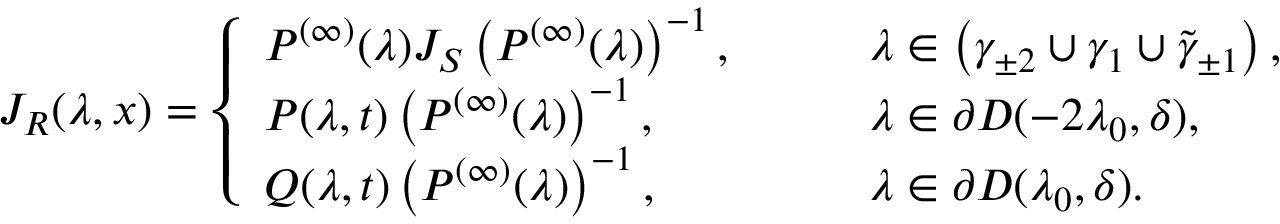<formula> <loc_0><loc_0><loc_500><loc_500>J _ { R } ( \lambda , x ) = \left \{ \begin{array} { l l } { P ^ { ( \infty ) } ( \lambda ) J _ { S } \left ( P ^ { ( \infty ) } ( \lambda ) \right ) ^ { - 1 } , } & { \quad \lambda \in \left ( \gamma _ { \pm 2 } \cup \gamma _ { 1 } \cup \tilde { \gamma } _ { \pm 1 } \right ) , } \\ { P ( \lambda , t ) \left ( P ^ { ( \infty ) } ( \lambda ) \right ) ^ { - 1 } , } & { \quad \lambda \in \partial D ( - 2 \lambda _ { 0 } , \delta ) , } \\ { Q ( \lambda , t ) \left ( P ^ { ( \infty ) } ( \lambda ) \right ) ^ { - 1 } , } & { \quad \lambda \in \partial D ( \lambda _ { 0 } , \delta ) . } \end{array}</formula> 